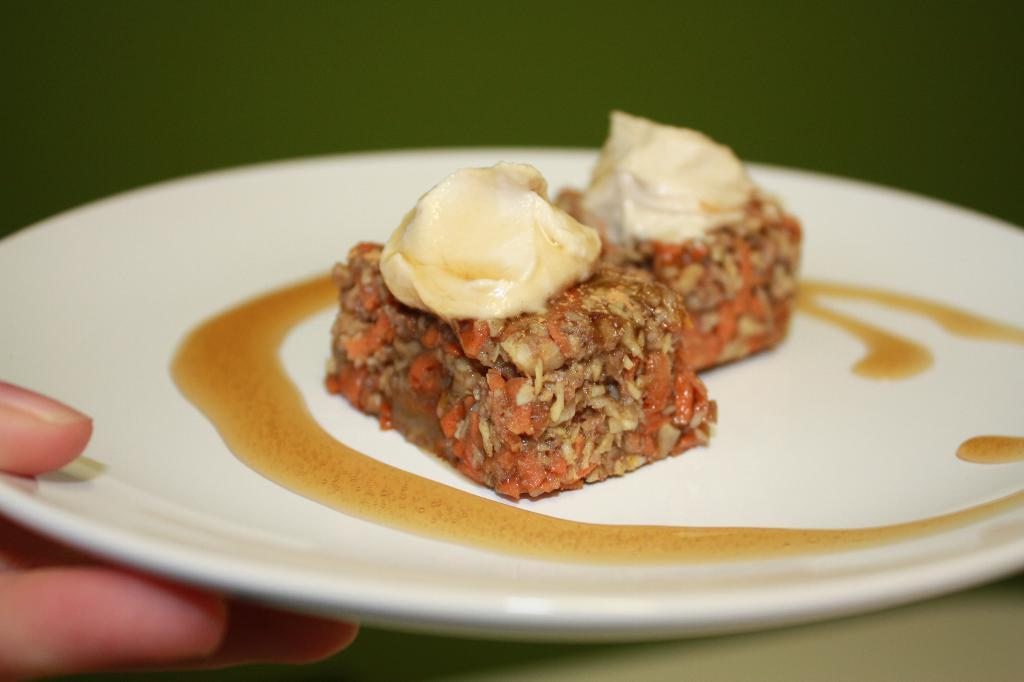What is on the plate that is visible in the image? There is food in the plate in the image. Whose hand is holding the plate in the image? There is a human hand holding the plate in the image. Can you describe the background of the image? The background of the image is blurry. What type of jewel is being used to garnish the food in the image? There is no jewel present in the image; it only features food on a plate being held by a hand. What type of berry can be seen growing in the background of the image? There is no berry present in the image, as the background is blurry and does not show any vegetation. 